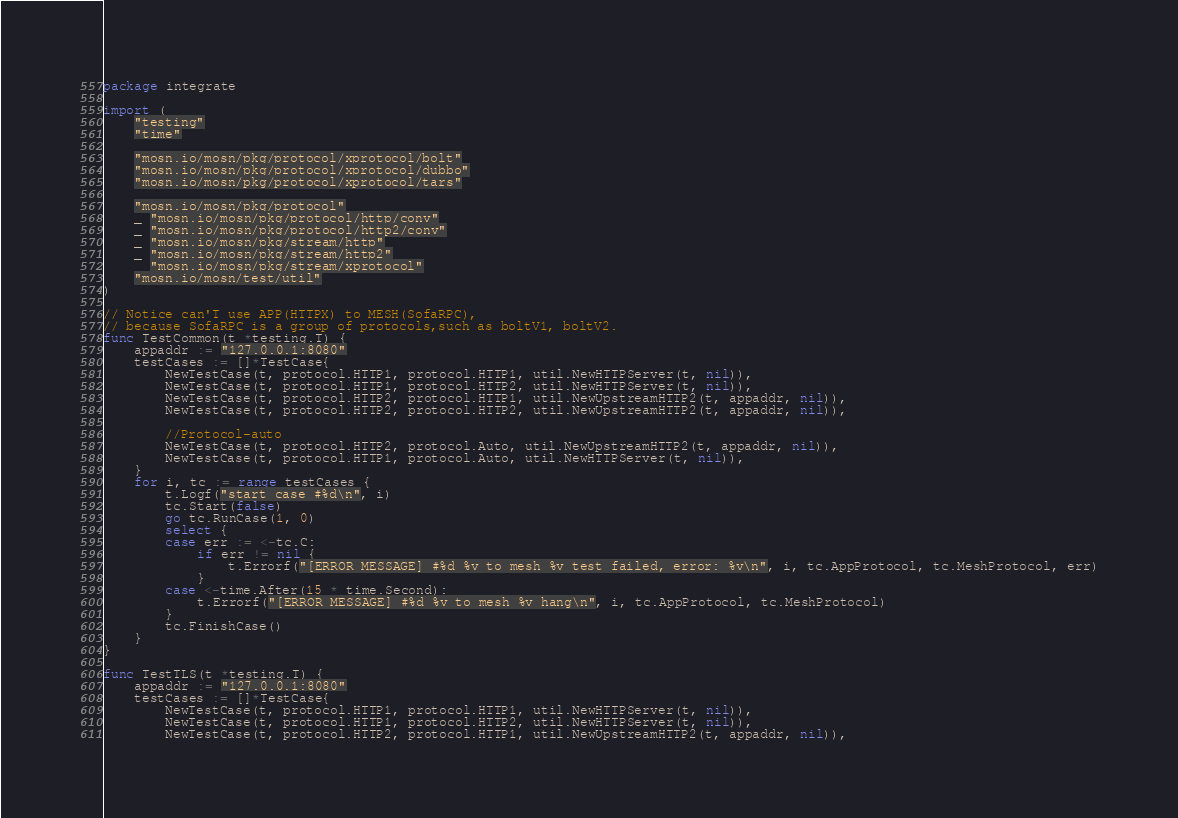<code> <loc_0><loc_0><loc_500><loc_500><_Go_>package integrate

import (
	"testing"
	"time"

	"mosn.io/mosn/pkg/protocol/xprotocol/bolt"
	"mosn.io/mosn/pkg/protocol/xprotocol/dubbo"
	"mosn.io/mosn/pkg/protocol/xprotocol/tars"

	"mosn.io/mosn/pkg/protocol"
	_ "mosn.io/mosn/pkg/protocol/http/conv"
	_ "mosn.io/mosn/pkg/protocol/http2/conv"
	_ "mosn.io/mosn/pkg/stream/http"
	_ "mosn.io/mosn/pkg/stream/http2"
	_ "mosn.io/mosn/pkg/stream/xprotocol"
	"mosn.io/mosn/test/util"
)

// Notice can'T use APP(HTTPX) to MESH(SofaRPC),
// because SofaRPC is a group of protocols,such as boltV1, boltV2.
func TestCommon(t *testing.T) {
	appaddr := "127.0.0.1:8080"
	testCases := []*TestCase{
		NewTestCase(t, protocol.HTTP1, protocol.HTTP1, util.NewHTTPServer(t, nil)),
		NewTestCase(t, protocol.HTTP1, protocol.HTTP2, util.NewHTTPServer(t, nil)),
		NewTestCase(t, protocol.HTTP2, protocol.HTTP1, util.NewUpstreamHTTP2(t, appaddr, nil)),
		NewTestCase(t, protocol.HTTP2, protocol.HTTP2, util.NewUpstreamHTTP2(t, appaddr, nil)),

		//Protocol-auto
		NewTestCase(t, protocol.HTTP2, protocol.Auto, util.NewUpstreamHTTP2(t, appaddr, nil)),
		NewTestCase(t, protocol.HTTP1, protocol.Auto, util.NewHTTPServer(t, nil)),
	}
	for i, tc := range testCases {
		t.Logf("start case #%d\n", i)
		tc.Start(false)
		go tc.RunCase(1, 0)
		select {
		case err := <-tc.C:
			if err != nil {
				t.Errorf("[ERROR MESSAGE] #%d %v to mesh %v test failed, error: %v\n", i, tc.AppProtocol, tc.MeshProtocol, err)
			}
		case <-time.After(15 * time.Second):
			t.Errorf("[ERROR MESSAGE] #%d %v to mesh %v hang\n", i, tc.AppProtocol, tc.MeshProtocol)
		}
		tc.FinishCase()
	}
}

func TestTLS(t *testing.T) {
	appaddr := "127.0.0.1:8080"
	testCases := []*TestCase{
		NewTestCase(t, protocol.HTTP1, protocol.HTTP1, util.NewHTTPServer(t, nil)),
		NewTestCase(t, protocol.HTTP1, protocol.HTTP2, util.NewHTTPServer(t, nil)),
		NewTestCase(t, protocol.HTTP2, protocol.HTTP1, util.NewUpstreamHTTP2(t, appaddr, nil)),</code> 